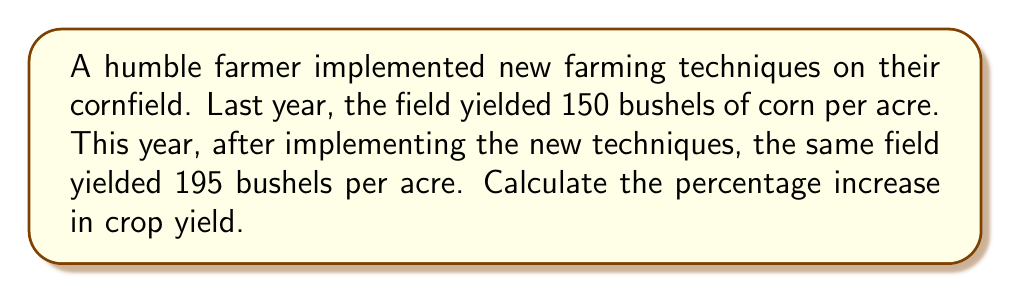What is the answer to this math problem? To calculate the percentage increase in crop yield, we need to follow these steps:

1. Calculate the difference in yield:
   $\text{Difference} = \text{New yield} - \text{Original yield}$
   $\text{Difference} = 195 - 150 = 45$ bushels per acre

2. Divide the difference by the original yield:
   $\frac{\text{Difference}}{\text{Original yield}} = \frac{45}{150} = 0.3$

3. Convert the result to a percentage by multiplying by 100:
   $\text{Percentage increase} = 0.3 \times 100 = 30\%$

Therefore, the percentage increase in crop yield can be calculated using the formula:

$$\text{Percentage increase} = \frac{\text{New yield} - \text{Original yield}}{\text{Original yield}} \times 100\%$$

Plugging in the values:

$$\text{Percentage increase} = \frac{195 - 150}{150} \times 100\% = \frac{45}{150} \times 100\% = 0.3 \times 100\% = 30\%$$
Answer: The percentage increase in crop yield after implementing new farming techniques is 30%. 